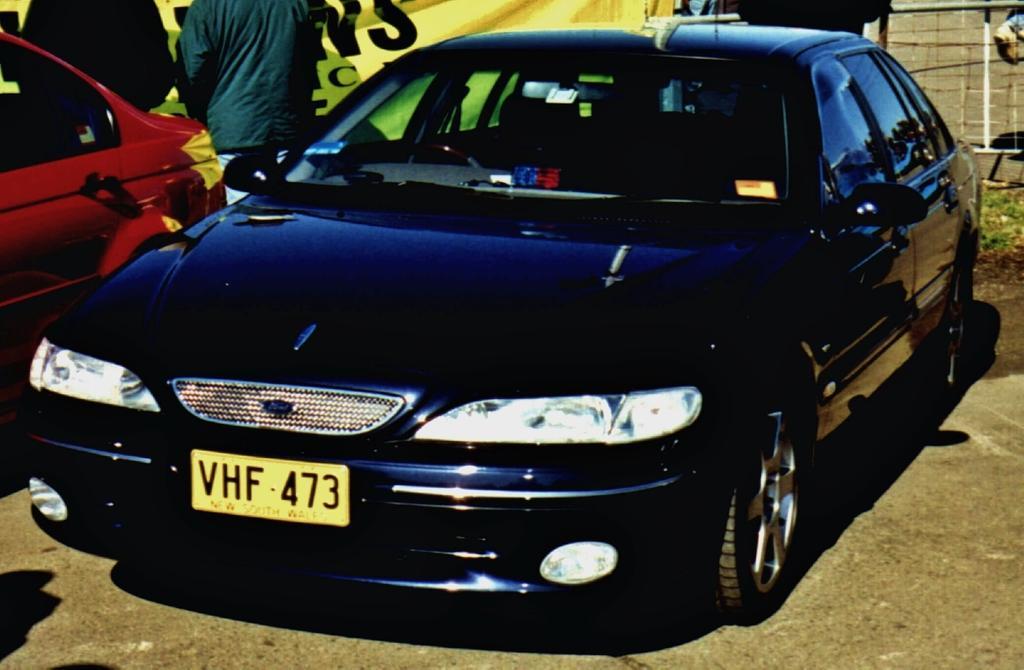How would you summarize this image in a sentence or two? In this image I see 2 cars in which this car is of red in color and this car is of blue in color and I see alphabets and numbers on this yellow color plate and I see 2 persons over here and I see the ground. In the background I see the yellow color banner on which there are alphabets. 